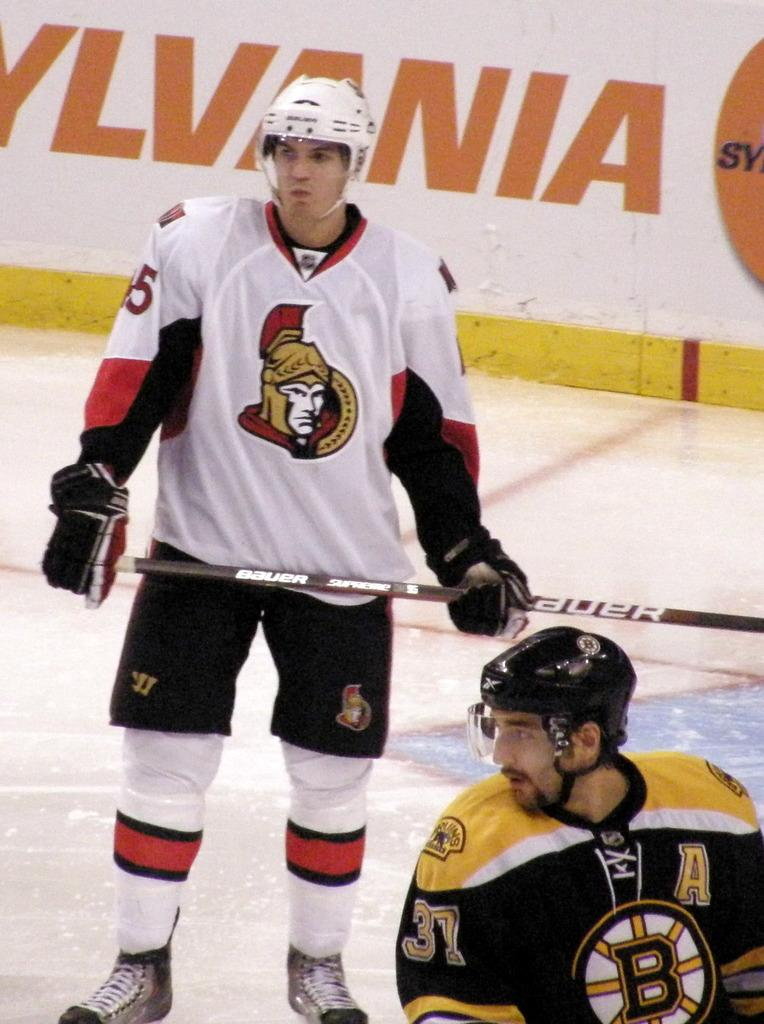What is the main subject of the image? There is a person standing and holding a bat in the center of the image. Can you describe the position of the person holding the bat? The person holding the bat is in the center of the image. Are there any other people visible in the image? Yes, there is another person in the bottom right corner of the image. What can be seen in the background of the image? There is a wall in the background of the image. What type of toothpaste is the person holding the bat using in the image? There is no toothpaste present in the image. 